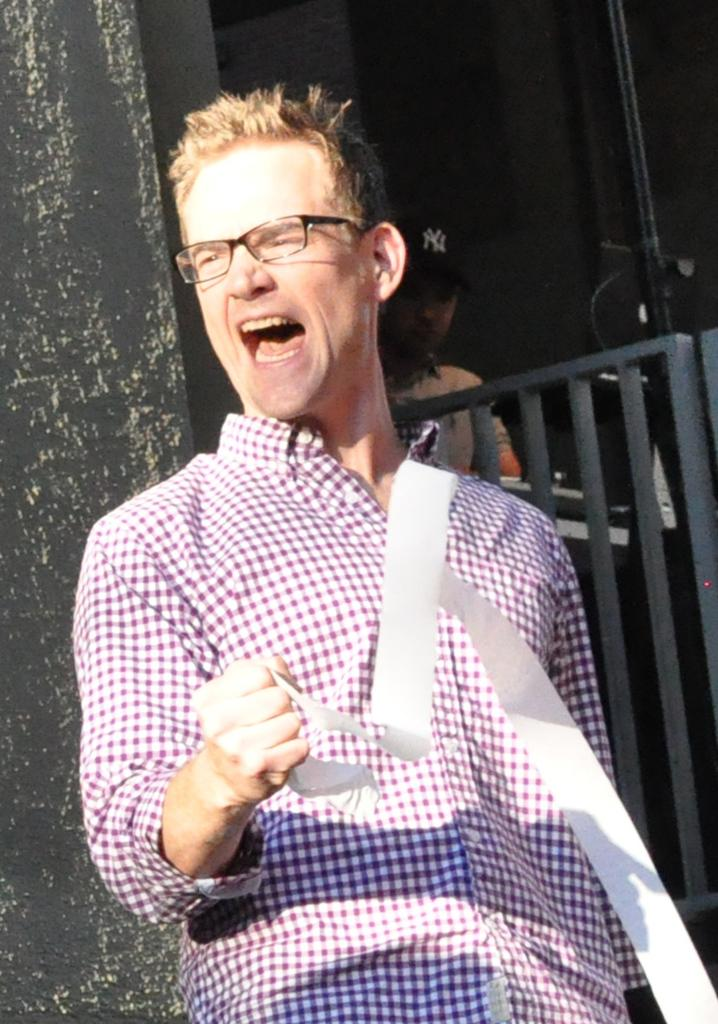What is the main subject of the image? There is a man standing in the image. What is the man wearing in the image? The man is wearing a pink shirt and glasses. Can you describe the other person in the image? There is at least one other person standing in the background of the image. What type of chin does the fireman have in the image? There is no fireman present in the image, and therefore no chin to describe. 